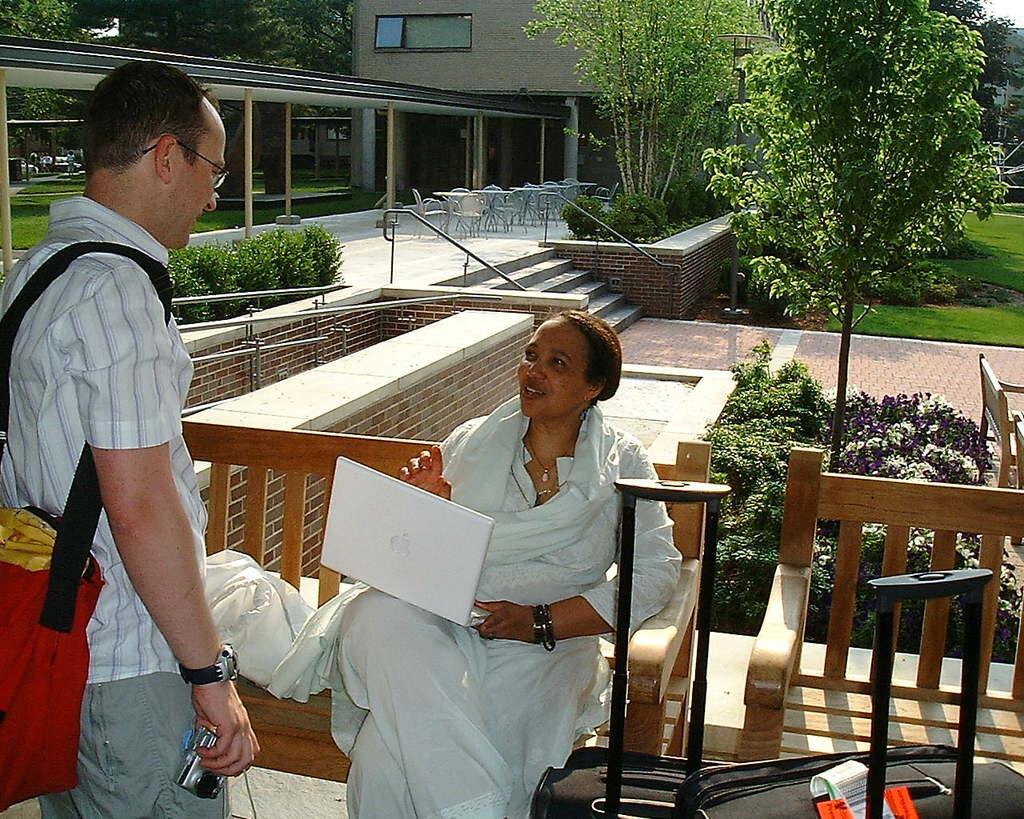Describe this image in one or two sentences. In this picture we can see a man and woman, she is seated on the bench and she is holding a laptop, in front of her we can see baggage, in the background we can find few plants, chairs, tables and buildings, and also we can see trees. 